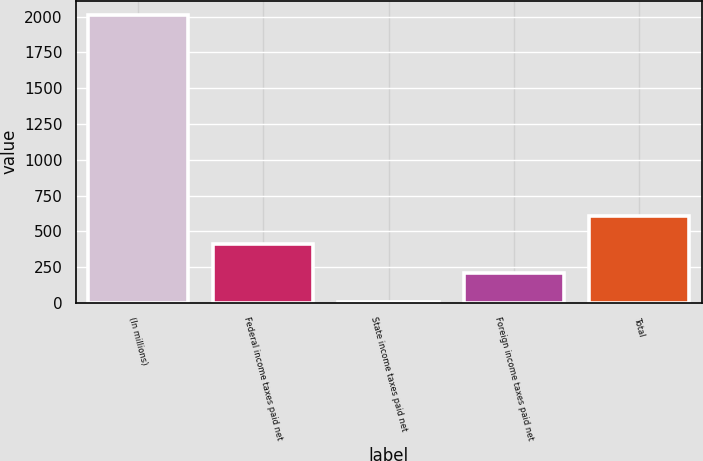<chart> <loc_0><loc_0><loc_500><loc_500><bar_chart><fcel>(In millions)<fcel>Federal income taxes paid net<fcel>State income taxes paid net<fcel>Foreign income taxes paid net<fcel>Total<nl><fcel>2012<fcel>409.84<fcel>9.3<fcel>209.57<fcel>610.11<nl></chart> 